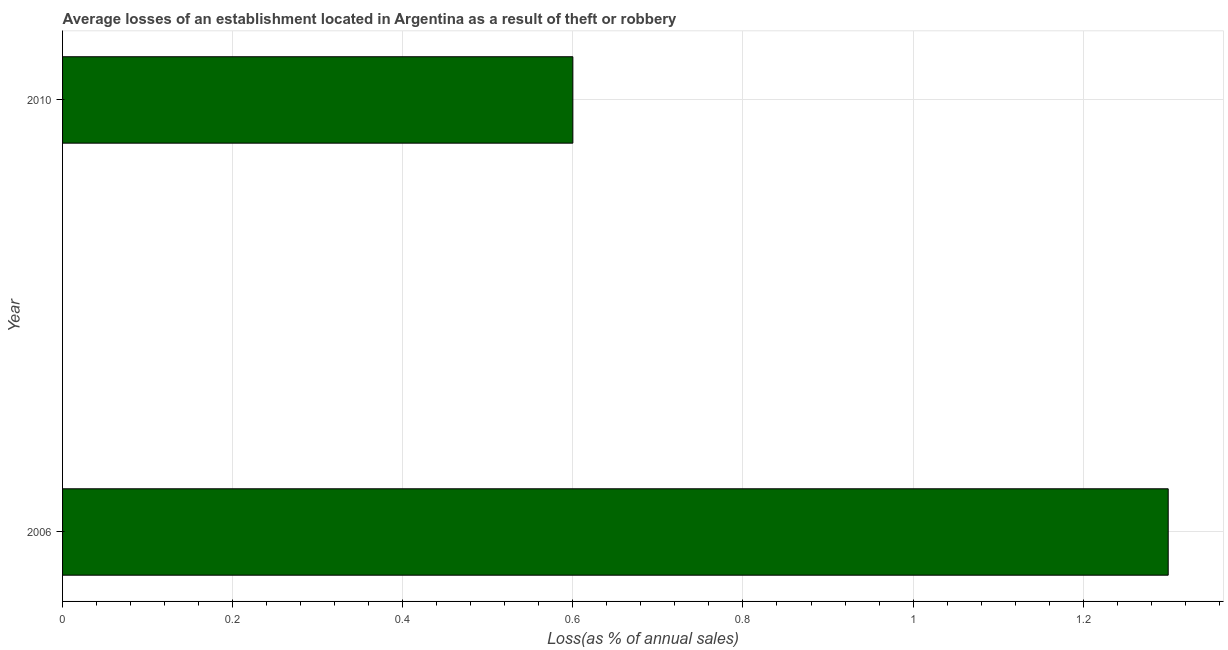Does the graph contain any zero values?
Ensure brevity in your answer.  No. What is the title of the graph?
Offer a terse response. Average losses of an establishment located in Argentina as a result of theft or robbery. What is the label or title of the X-axis?
Provide a short and direct response. Loss(as % of annual sales). In which year was the losses due to theft maximum?
Give a very brief answer. 2006. In which year was the losses due to theft minimum?
Keep it short and to the point. 2010. What is the sum of the losses due to theft?
Offer a very short reply. 1.9. What is the average losses due to theft per year?
Your answer should be compact. 0.95. What is the median losses due to theft?
Keep it short and to the point. 0.95. In how many years, is the losses due to theft greater than 1.2 %?
Offer a terse response. 1. What is the ratio of the losses due to theft in 2006 to that in 2010?
Your response must be concise. 2.17. Are all the bars in the graph horizontal?
Offer a terse response. Yes. Are the values on the major ticks of X-axis written in scientific E-notation?
Your response must be concise. No. What is the Loss(as % of annual sales) in 2006?
Provide a short and direct response. 1.3. What is the Loss(as % of annual sales) of 2010?
Your response must be concise. 0.6. What is the ratio of the Loss(as % of annual sales) in 2006 to that in 2010?
Give a very brief answer. 2.17. 